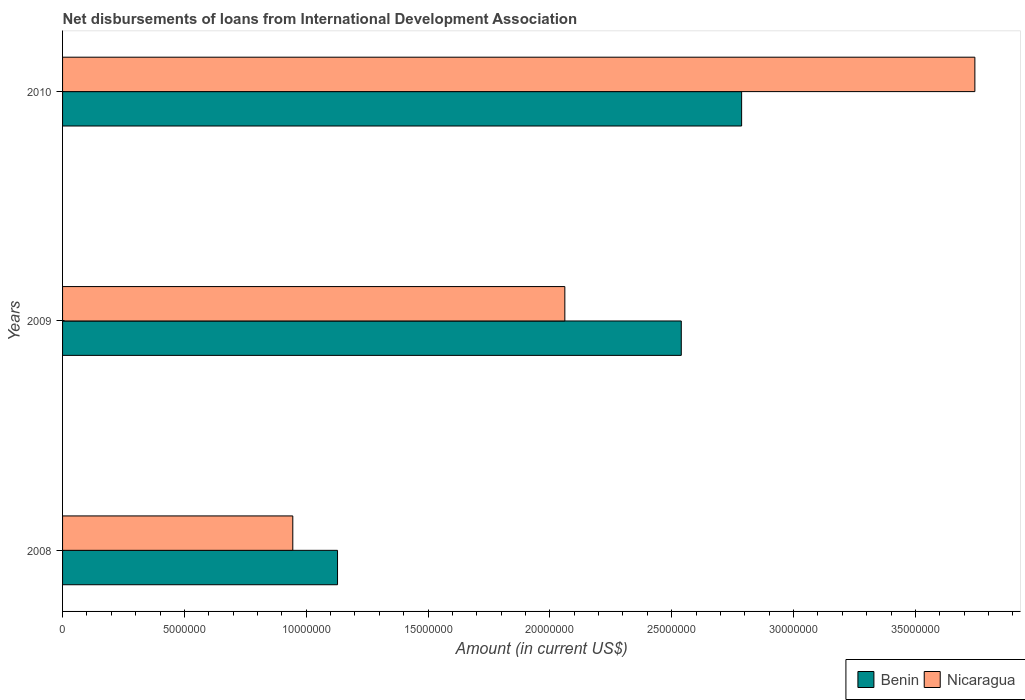How many different coloured bars are there?
Ensure brevity in your answer.  2. How many groups of bars are there?
Give a very brief answer. 3. How many bars are there on the 3rd tick from the top?
Your response must be concise. 2. What is the amount of loans disbursed in Benin in 2010?
Provide a succinct answer. 2.79e+07. Across all years, what is the maximum amount of loans disbursed in Nicaragua?
Make the answer very short. 3.74e+07. Across all years, what is the minimum amount of loans disbursed in Benin?
Offer a terse response. 1.13e+07. In which year was the amount of loans disbursed in Benin maximum?
Provide a succinct answer. 2010. What is the total amount of loans disbursed in Nicaragua in the graph?
Your answer should be very brief. 6.75e+07. What is the difference between the amount of loans disbursed in Nicaragua in 2008 and that in 2010?
Offer a terse response. -2.80e+07. What is the difference between the amount of loans disbursed in Benin in 2010 and the amount of loans disbursed in Nicaragua in 2009?
Provide a short and direct response. 7.26e+06. What is the average amount of loans disbursed in Nicaragua per year?
Offer a terse response. 2.25e+07. In the year 2009, what is the difference between the amount of loans disbursed in Benin and amount of loans disbursed in Nicaragua?
Keep it short and to the point. 4.78e+06. What is the ratio of the amount of loans disbursed in Nicaragua in 2009 to that in 2010?
Provide a short and direct response. 0.55. Is the difference between the amount of loans disbursed in Benin in 2008 and 2010 greater than the difference between the amount of loans disbursed in Nicaragua in 2008 and 2010?
Your answer should be very brief. Yes. What is the difference between the highest and the second highest amount of loans disbursed in Nicaragua?
Your answer should be compact. 1.68e+07. What is the difference between the highest and the lowest amount of loans disbursed in Benin?
Offer a terse response. 1.66e+07. In how many years, is the amount of loans disbursed in Benin greater than the average amount of loans disbursed in Benin taken over all years?
Keep it short and to the point. 2. What does the 2nd bar from the top in 2010 represents?
Your answer should be very brief. Benin. What does the 1st bar from the bottom in 2010 represents?
Provide a succinct answer. Benin. How many bars are there?
Provide a succinct answer. 6. What is the difference between two consecutive major ticks on the X-axis?
Provide a short and direct response. 5.00e+06. Are the values on the major ticks of X-axis written in scientific E-notation?
Offer a very short reply. No. Does the graph contain any zero values?
Give a very brief answer. No. Where does the legend appear in the graph?
Keep it short and to the point. Bottom right. How are the legend labels stacked?
Provide a succinct answer. Horizontal. What is the title of the graph?
Provide a short and direct response. Net disbursements of loans from International Development Association. Does "Dominican Republic" appear as one of the legend labels in the graph?
Offer a very short reply. No. What is the label or title of the Y-axis?
Offer a terse response. Years. What is the Amount (in current US$) of Benin in 2008?
Your response must be concise. 1.13e+07. What is the Amount (in current US$) in Nicaragua in 2008?
Your answer should be compact. 9.45e+06. What is the Amount (in current US$) in Benin in 2009?
Offer a terse response. 2.54e+07. What is the Amount (in current US$) of Nicaragua in 2009?
Your answer should be compact. 2.06e+07. What is the Amount (in current US$) in Benin in 2010?
Your answer should be compact. 2.79e+07. What is the Amount (in current US$) of Nicaragua in 2010?
Offer a very short reply. 3.74e+07. Across all years, what is the maximum Amount (in current US$) in Benin?
Your answer should be very brief. 2.79e+07. Across all years, what is the maximum Amount (in current US$) of Nicaragua?
Keep it short and to the point. 3.74e+07. Across all years, what is the minimum Amount (in current US$) of Benin?
Keep it short and to the point. 1.13e+07. Across all years, what is the minimum Amount (in current US$) of Nicaragua?
Your answer should be very brief. 9.45e+06. What is the total Amount (in current US$) in Benin in the graph?
Offer a very short reply. 6.45e+07. What is the total Amount (in current US$) in Nicaragua in the graph?
Provide a short and direct response. 6.75e+07. What is the difference between the Amount (in current US$) in Benin in 2008 and that in 2009?
Provide a short and direct response. -1.41e+07. What is the difference between the Amount (in current US$) of Nicaragua in 2008 and that in 2009?
Ensure brevity in your answer.  -1.12e+07. What is the difference between the Amount (in current US$) of Benin in 2008 and that in 2010?
Provide a succinct answer. -1.66e+07. What is the difference between the Amount (in current US$) in Nicaragua in 2008 and that in 2010?
Your answer should be compact. -2.80e+07. What is the difference between the Amount (in current US$) of Benin in 2009 and that in 2010?
Offer a terse response. -2.48e+06. What is the difference between the Amount (in current US$) of Nicaragua in 2009 and that in 2010?
Provide a short and direct response. -1.68e+07. What is the difference between the Amount (in current US$) of Benin in 2008 and the Amount (in current US$) of Nicaragua in 2009?
Keep it short and to the point. -9.33e+06. What is the difference between the Amount (in current US$) of Benin in 2008 and the Amount (in current US$) of Nicaragua in 2010?
Offer a very short reply. -2.62e+07. What is the difference between the Amount (in current US$) of Benin in 2009 and the Amount (in current US$) of Nicaragua in 2010?
Your response must be concise. -1.20e+07. What is the average Amount (in current US$) in Benin per year?
Offer a terse response. 2.15e+07. What is the average Amount (in current US$) in Nicaragua per year?
Offer a terse response. 2.25e+07. In the year 2008, what is the difference between the Amount (in current US$) of Benin and Amount (in current US$) of Nicaragua?
Give a very brief answer. 1.84e+06. In the year 2009, what is the difference between the Amount (in current US$) in Benin and Amount (in current US$) in Nicaragua?
Your response must be concise. 4.78e+06. In the year 2010, what is the difference between the Amount (in current US$) in Benin and Amount (in current US$) in Nicaragua?
Provide a succinct answer. -9.57e+06. What is the ratio of the Amount (in current US$) of Benin in 2008 to that in 2009?
Provide a short and direct response. 0.44. What is the ratio of the Amount (in current US$) in Nicaragua in 2008 to that in 2009?
Ensure brevity in your answer.  0.46. What is the ratio of the Amount (in current US$) of Benin in 2008 to that in 2010?
Provide a succinct answer. 0.4. What is the ratio of the Amount (in current US$) in Nicaragua in 2008 to that in 2010?
Offer a terse response. 0.25. What is the ratio of the Amount (in current US$) in Benin in 2009 to that in 2010?
Your response must be concise. 0.91. What is the ratio of the Amount (in current US$) of Nicaragua in 2009 to that in 2010?
Provide a succinct answer. 0.55. What is the difference between the highest and the second highest Amount (in current US$) in Benin?
Your answer should be very brief. 2.48e+06. What is the difference between the highest and the second highest Amount (in current US$) of Nicaragua?
Provide a succinct answer. 1.68e+07. What is the difference between the highest and the lowest Amount (in current US$) of Benin?
Provide a short and direct response. 1.66e+07. What is the difference between the highest and the lowest Amount (in current US$) of Nicaragua?
Keep it short and to the point. 2.80e+07. 